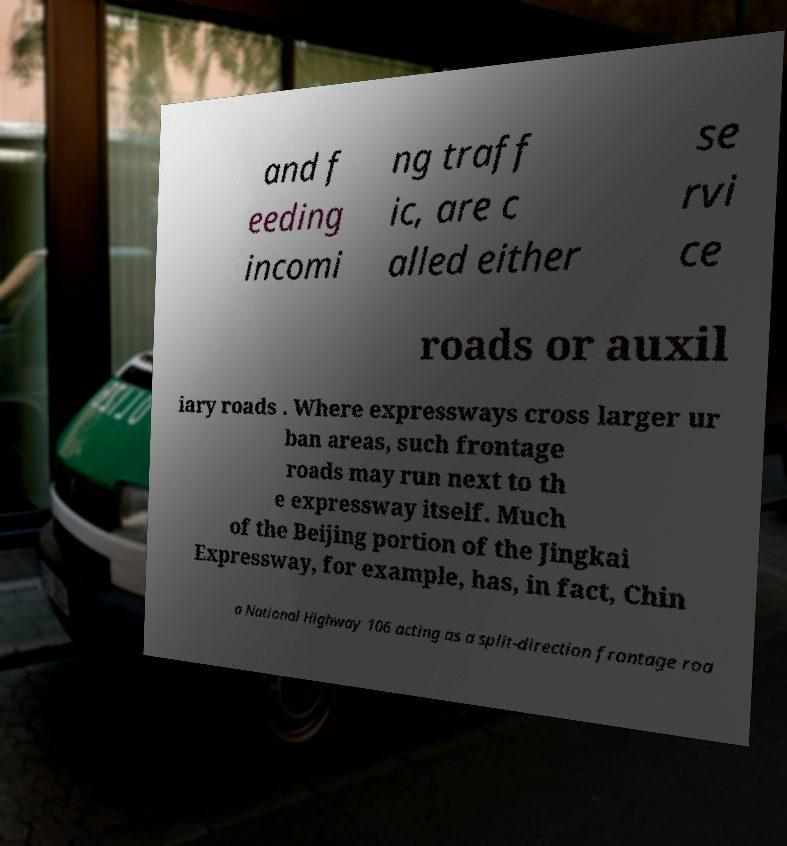Can you accurately transcribe the text from the provided image for me? and f eeding incomi ng traff ic, are c alled either se rvi ce roads or auxil iary roads . Where expressways cross larger ur ban areas, such frontage roads may run next to th e expressway itself. Much of the Beijing portion of the Jingkai Expressway, for example, has, in fact, Chin a National Highway 106 acting as a split-direction frontage roa 